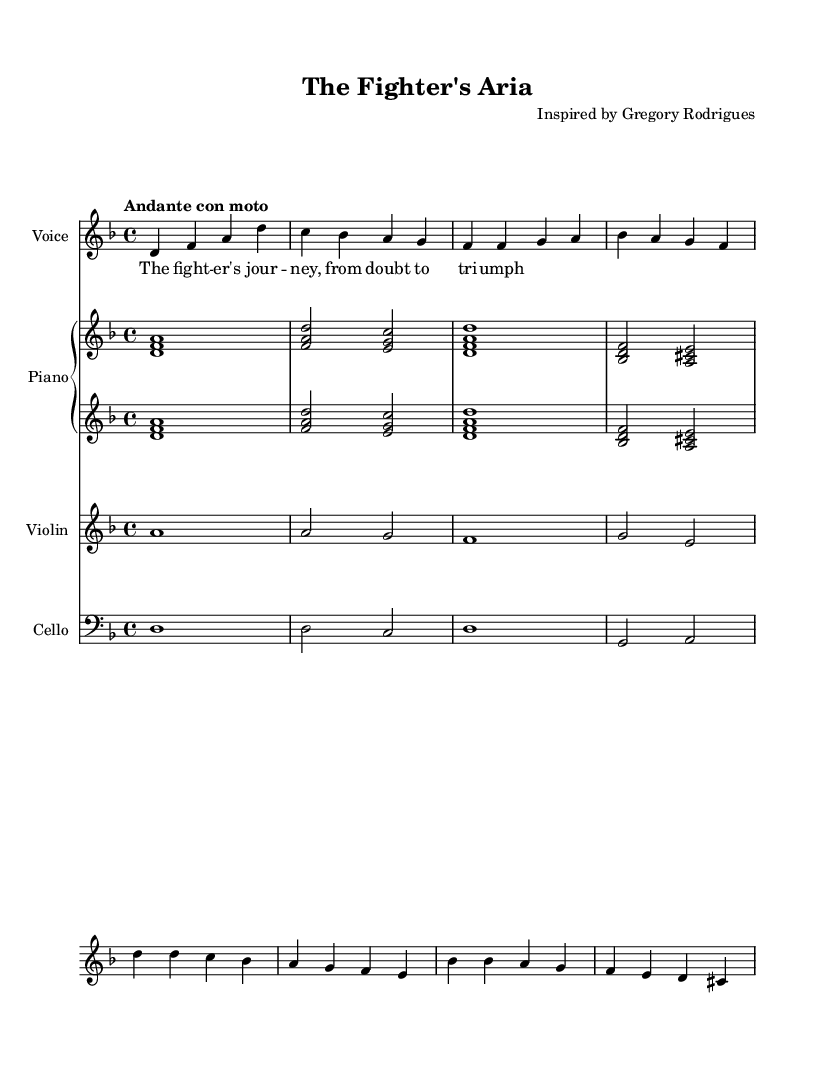What is the key signature of this music? The key signature indicated in the music is D minor, which has one flat (B flat). This can be determined from the initial part of the sheet music.
Answer: D minor What is the time signature? The time signature shown in the music is 4/4, indicating there are four beats in each measure. This can be inferred from the notation at the beginning of the score.
Answer: 4/4 What is the tempo marking? The tempo marking in the music indicates "Andante con moto," suggesting a moderately slow tempo with a slight movement. This can be found right after the time signature.
Answer: Andante con moto How many measures are in the provided music? By counting the measures in the provided musical phrases, there are a total of 8 measures represented in the music. Each group of notes separated by vertical lines indicates one measure.
Answer: 8 What is the instrumentation listed in the score? The instrumentation includes Voice, Piano, Violin, and Cello. This information is typically noted at the beginning of the score within the staff labels.
Answer: Voice, Piano, Violin, Cello Which section contains the chorus? The chorus is represented in the music where it transitions into the lines starting with d' d c bes a g f e. This can be identified by observing the structure and phrasing of the score.
Answer: Chorus 